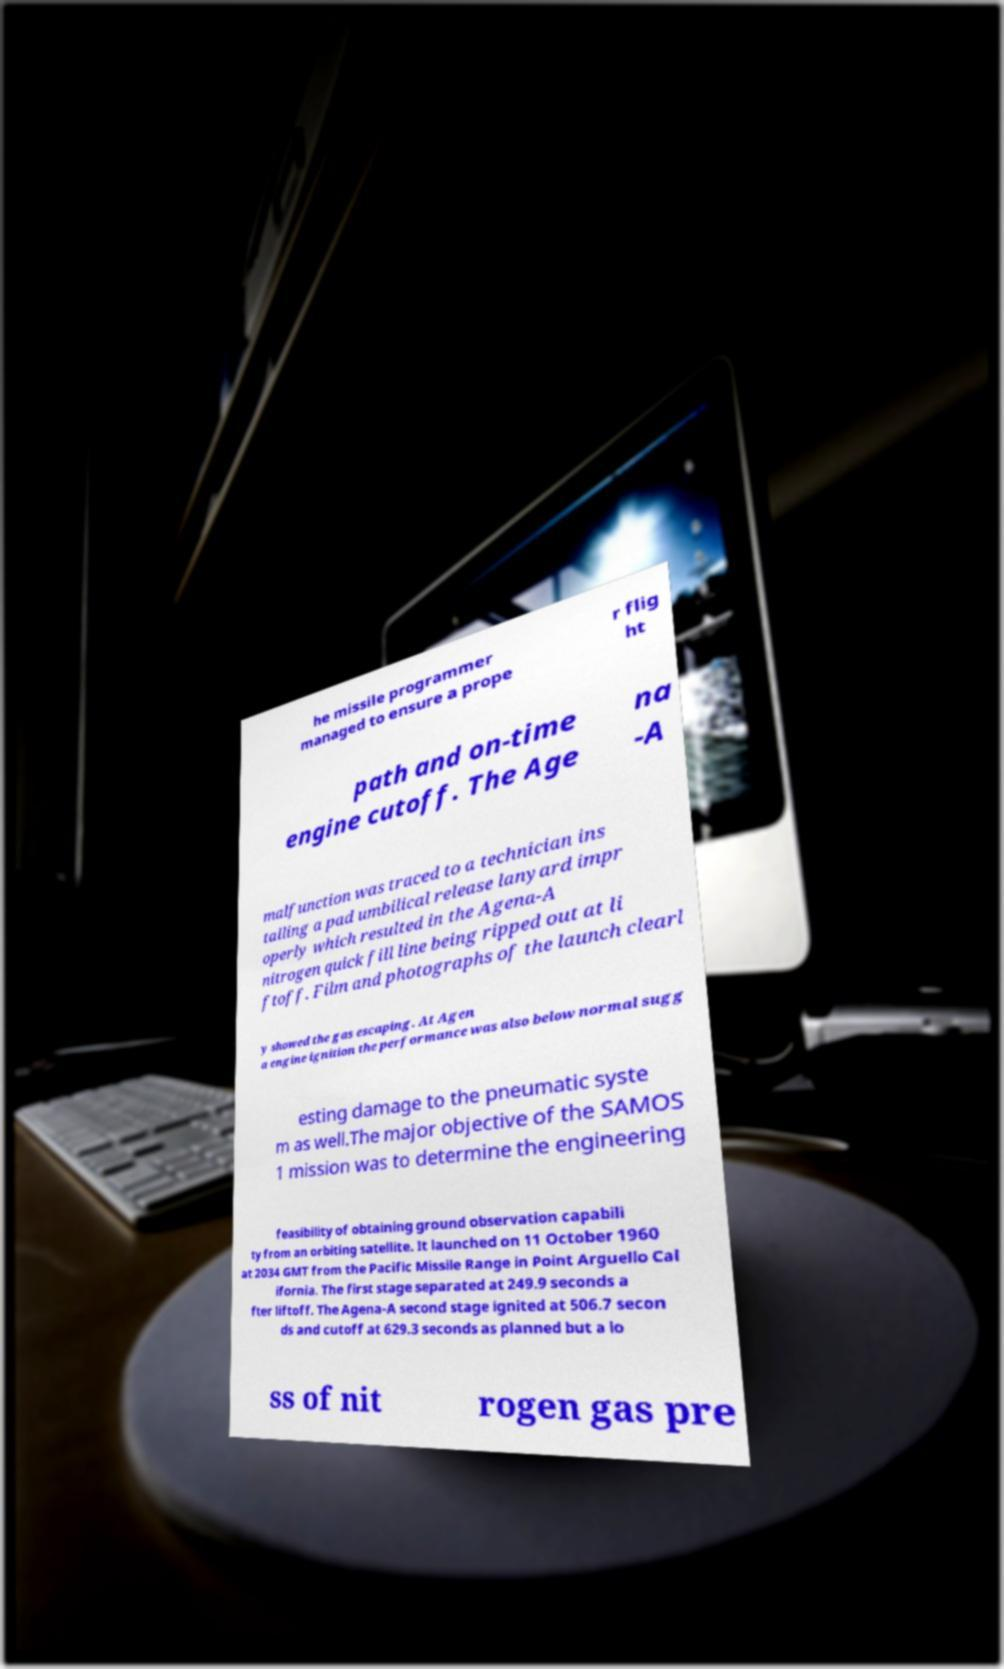Can you read and provide the text displayed in the image?This photo seems to have some interesting text. Can you extract and type it out for me? he missile programmer managed to ensure a prope r flig ht path and on-time engine cutoff. The Age na -A malfunction was traced to a technician ins talling a pad umbilical release lanyard impr operly which resulted in the Agena-A nitrogen quick fill line being ripped out at li ftoff. Film and photographs of the launch clearl y showed the gas escaping. At Agen a engine ignition the performance was also below normal sugg esting damage to the pneumatic syste m as well.The major objective of the SAMOS 1 mission was to determine the engineering feasibility of obtaining ground observation capabili ty from an orbiting satellite. It launched on 11 October 1960 at 2034 GMT from the Pacific Missile Range in Point Arguello Cal ifornia. The first stage separated at 249.9 seconds a fter liftoff. The Agena-A second stage ignited at 506.7 secon ds and cutoff at 629.3 seconds as planned but a lo ss of nit rogen gas pre 